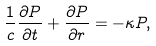Convert formula to latex. <formula><loc_0><loc_0><loc_500><loc_500>\frac { 1 } { c } \frac { \partial P } { \partial t } + \frac { \partial P } { \partial r } = - \kappa P ,</formula> 